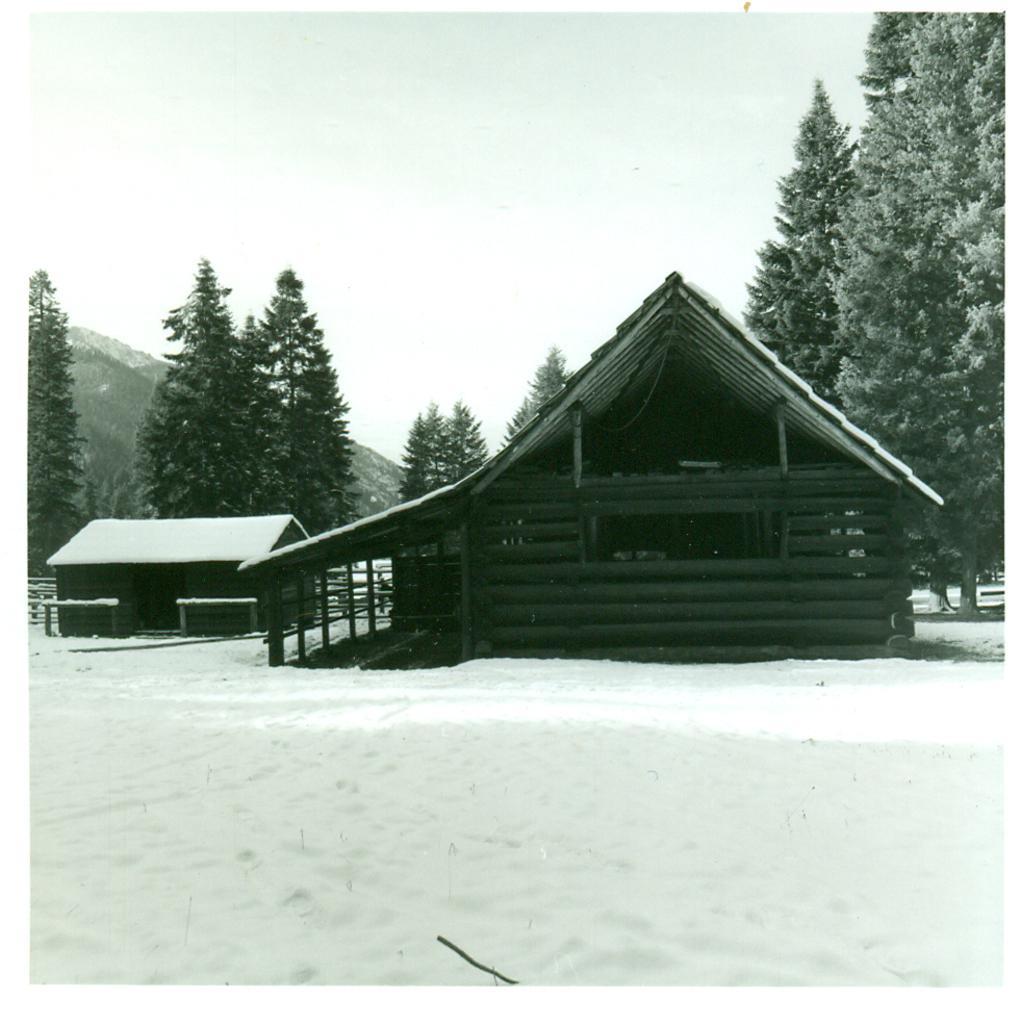Describe this image in one or two sentences. There are two wooden houses covered with snow and there are trees in the background. 